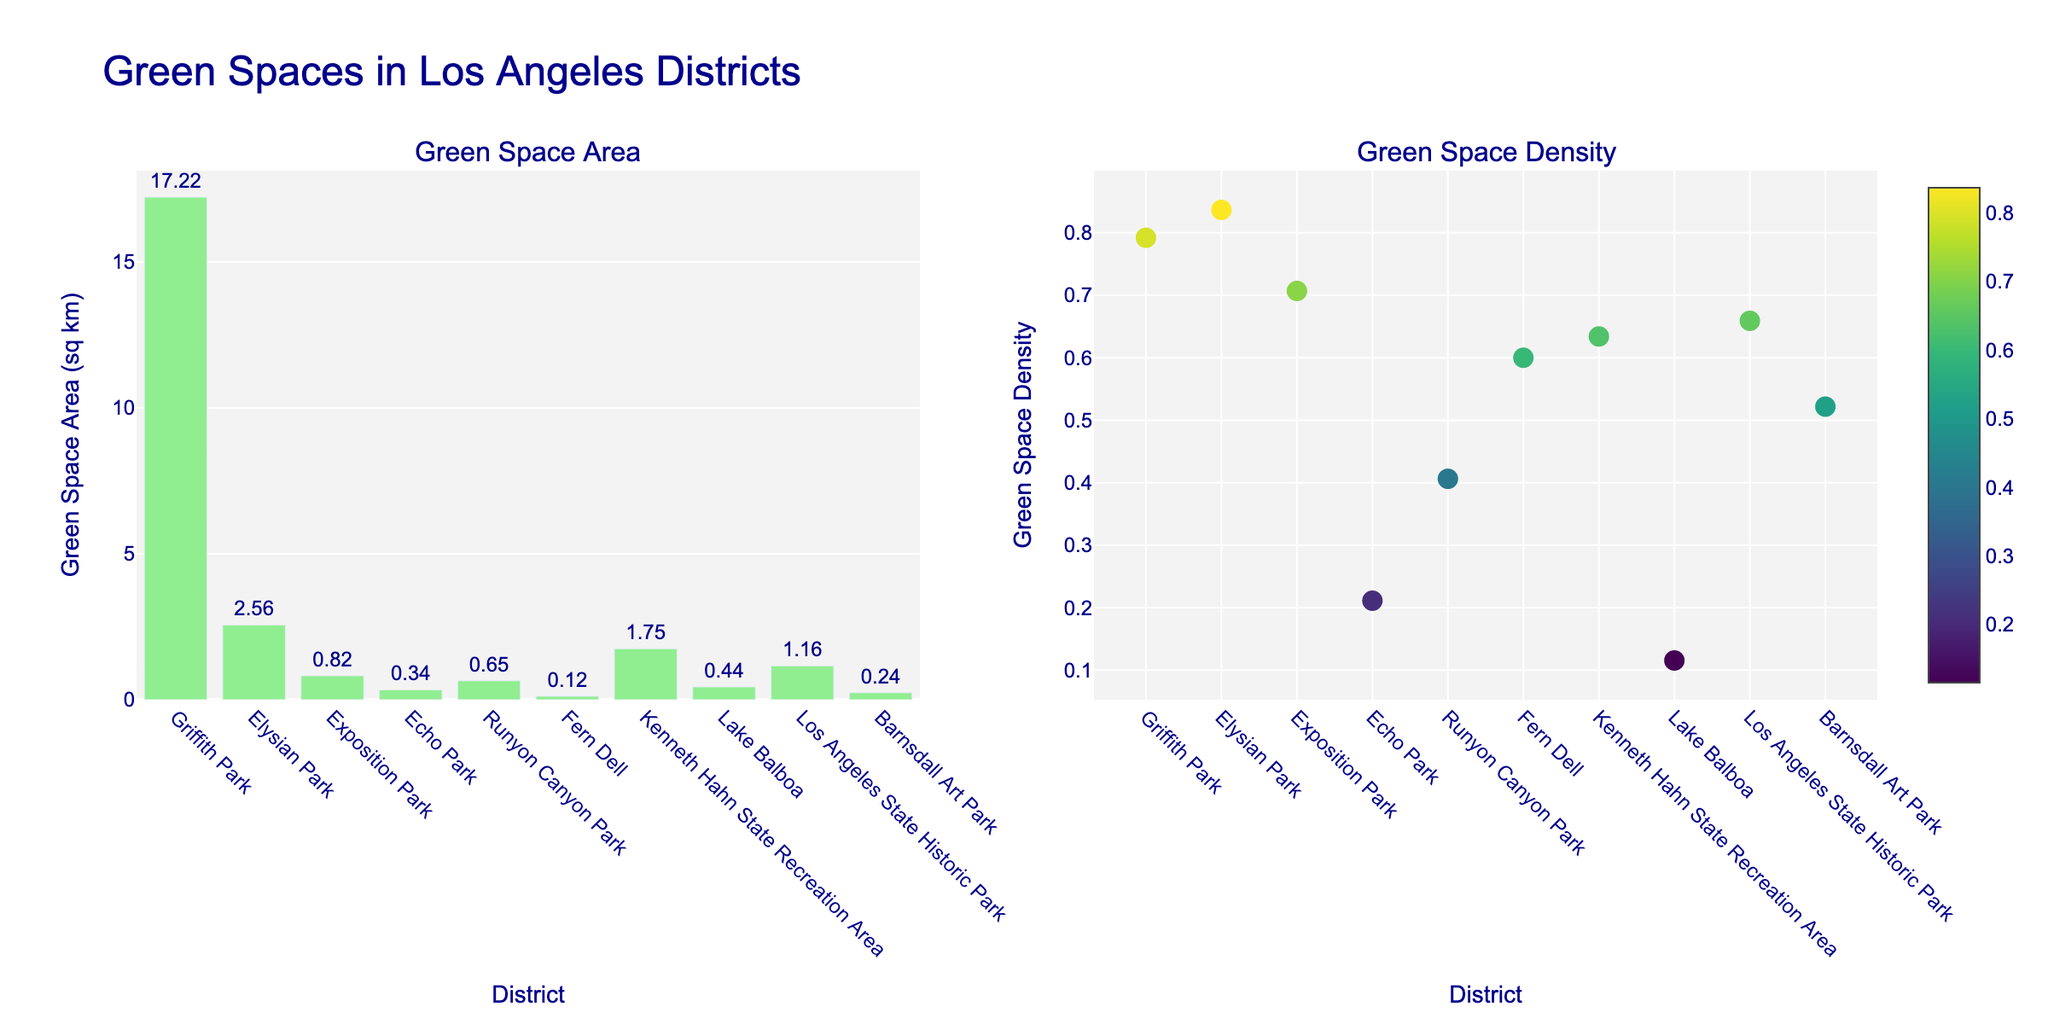What's the title of the plot? The title is located at the top of the plot and reads "Green Spaces in Los Angeles Districts."
Answer: Green Spaces in Los Angeles Districts How many green spaces are represented in the bar plot? The bar plot shows one bar for each district listed. Counting the bars provides the number of green spaces.
Answer: 10 What is the color used in the density scatter plot? The scatter plot uses a gradient color scale and shows various shades within the Viridis colorscale, ranging from dark to light.
Answer: Viridis colorscale Which district has the highest green space area? By looking at the highest bar in the bar plot, we can see that Griffith Park has the highest green space area.
Answer: Griffith Park What is the green space density for Echo Park? Find the marker point corresponding to Echo Park in the scatter plot and read the density value next to it.
Answer: 0.211 Which district has the lowest green space density? Identify the marker point at the lowest position in the y-axis of the scatter plot; it represents Fern Dell.
Answer: Fern Dell Compare the green space areas of Exposition Park and Kenneth Hahn State Recreation Area. Exposition Park's green space is represented by a bar lower than Kenneth Hahn State Recreation Area's bar. Reading the bars' values shows that Exposition Park has 0.82 sq km and Kenneth Hahn State Recreation Area has 1.75 sq km.
Answer: Kenneth Hahn State Recreation Area > Exposition Park What is the average green space density across all districts? The densities must be added and then divided by the number of districts. (0.792 + 0.836 + 0.707 + 0.211 + 0.406 + 0.6 + 0.634 + 0.115 + 0.659 + 0.522) / 10 = 5.482 / 10
Answer: 0.548 Which district has a larger green space density, Echo Park or Lake Balboa? Compare the positions of Echo Park and Lake Balboa markers on the scatter plot; Echo Park has 0.211 and Lake Balboa has 0.115.
Answer: Echo Park 